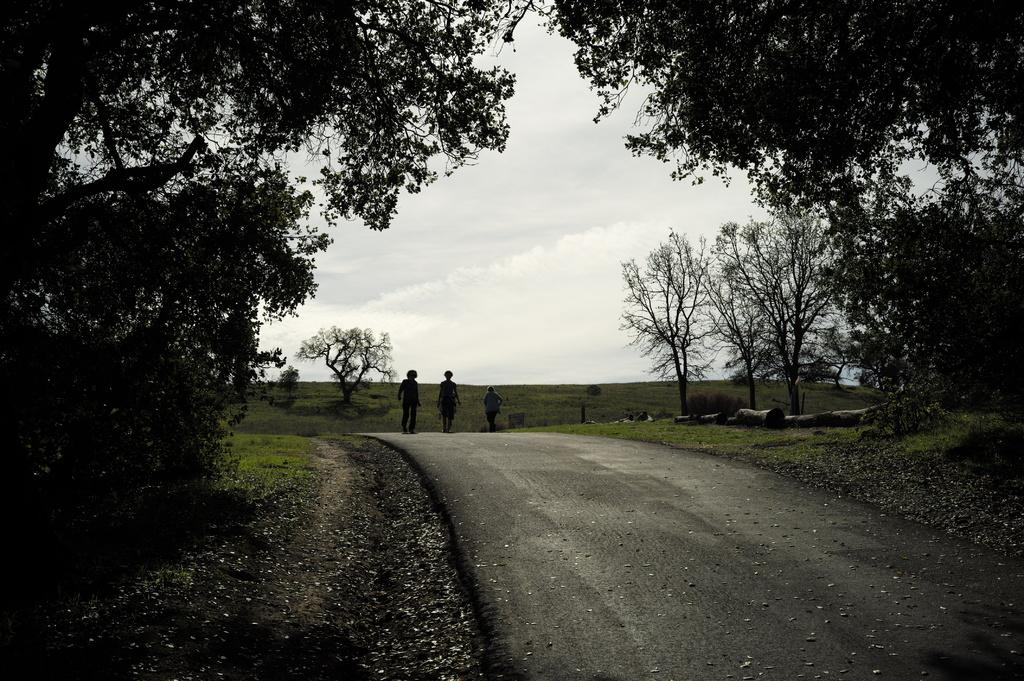What are the people in the image doing? The people in the image are walking on the road. What can be seen on both sides of the road? There are trees on both sides of the road. What type of vegetation is visible in the background of the image? There is grass visible in the background of the image. What is visible in the sky in the image? The sky is visible in the background of the image. What type of ball is being thrown in the image? There is no ball present in the image; it features people walking on the road with trees on both sides and a visible sky. 